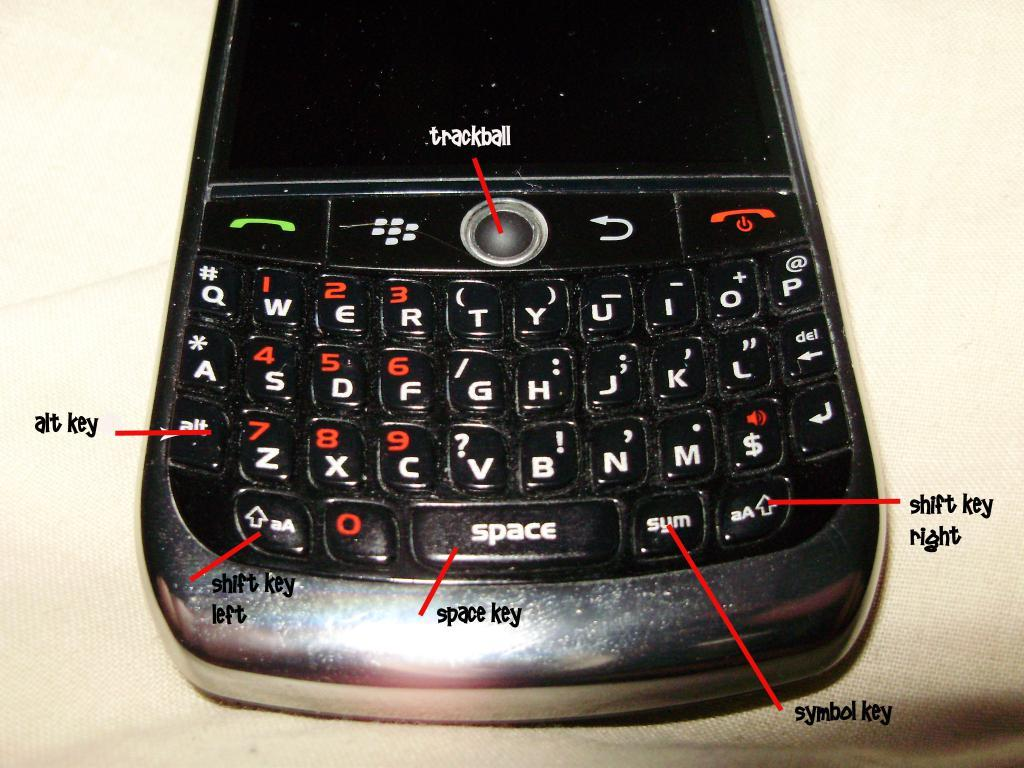Provide a one-sentence caption for the provided image. I diagram of the keys on a Blackberry phone that include things like the alt and space key. 